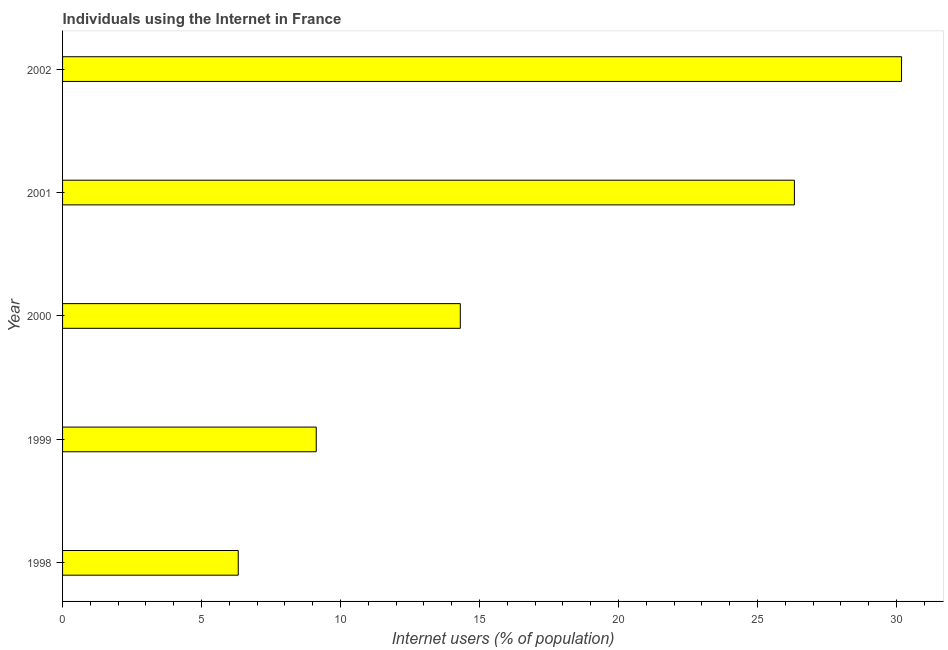What is the title of the graph?
Provide a short and direct response. Individuals using the Internet in France. What is the label or title of the X-axis?
Make the answer very short. Internet users (% of population). What is the label or title of the Y-axis?
Your answer should be very brief. Year. What is the number of internet users in 1999?
Your answer should be compact. 9.13. Across all years, what is the maximum number of internet users?
Provide a short and direct response. 30.18. Across all years, what is the minimum number of internet users?
Provide a succinct answer. 6.32. In which year was the number of internet users maximum?
Offer a terse response. 2002. What is the sum of the number of internet users?
Give a very brief answer. 86.26. What is the difference between the number of internet users in 2000 and 2001?
Ensure brevity in your answer.  -12.02. What is the average number of internet users per year?
Provide a short and direct response. 17.25. What is the median number of internet users?
Make the answer very short. 14.31. What is the ratio of the number of internet users in 2001 to that in 2002?
Give a very brief answer. 0.87. Is the number of internet users in 1998 less than that in 2001?
Your answer should be compact. Yes. Is the difference between the number of internet users in 2000 and 2001 greater than the difference between any two years?
Keep it short and to the point. No. What is the difference between the highest and the second highest number of internet users?
Ensure brevity in your answer.  3.85. What is the difference between the highest and the lowest number of internet users?
Ensure brevity in your answer.  23.86. What is the difference between two consecutive major ticks on the X-axis?
Give a very brief answer. 5. Are the values on the major ticks of X-axis written in scientific E-notation?
Ensure brevity in your answer.  No. What is the Internet users (% of population) in 1998?
Your response must be concise. 6.32. What is the Internet users (% of population) of 1999?
Your answer should be compact. 9.13. What is the Internet users (% of population) in 2000?
Offer a very short reply. 14.31. What is the Internet users (% of population) in 2001?
Offer a terse response. 26.33. What is the Internet users (% of population) of 2002?
Your answer should be compact. 30.18. What is the difference between the Internet users (% of population) in 1998 and 1999?
Offer a very short reply. -2.81. What is the difference between the Internet users (% of population) in 1998 and 2000?
Make the answer very short. -7.99. What is the difference between the Internet users (% of population) in 1998 and 2001?
Provide a short and direct response. -20.01. What is the difference between the Internet users (% of population) in 1998 and 2002?
Make the answer very short. -23.86. What is the difference between the Internet users (% of population) in 1999 and 2000?
Your answer should be compact. -5.18. What is the difference between the Internet users (% of population) in 1999 and 2001?
Offer a very short reply. -17.2. What is the difference between the Internet users (% of population) in 1999 and 2002?
Provide a short and direct response. -21.05. What is the difference between the Internet users (% of population) in 2000 and 2001?
Keep it short and to the point. -12.02. What is the difference between the Internet users (% of population) in 2000 and 2002?
Offer a very short reply. -15.87. What is the difference between the Internet users (% of population) in 2001 and 2002?
Ensure brevity in your answer.  -3.85. What is the ratio of the Internet users (% of population) in 1998 to that in 1999?
Provide a succinct answer. 0.69. What is the ratio of the Internet users (% of population) in 1998 to that in 2000?
Give a very brief answer. 0.44. What is the ratio of the Internet users (% of population) in 1998 to that in 2001?
Your response must be concise. 0.24. What is the ratio of the Internet users (% of population) in 1998 to that in 2002?
Keep it short and to the point. 0.21. What is the ratio of the Internet users (% of population) in 1999 to that in 2000?
Provide a succinct answer. 0.64. What is the ratio of the Internet users (% of population) in 1999 to that in 2001?
Your answer should be very brief. 0.35. What is the ratio of the Internet users (% of population) in 1999 to that in 2002?
Your response must be concise. 0.3. What is the ratio of the Internet users (% of population) in 2000 to that in 2001?
Offer a terse response. 0.54. What is the ratio of the Internet users (% of population) in 2000 to that in 2002?
Offer a terse response. 0.47. What is the ratio of the Internet users (% of population) in 2001 to that in 2002?
Ensure brevity in your answer.  0.87. 